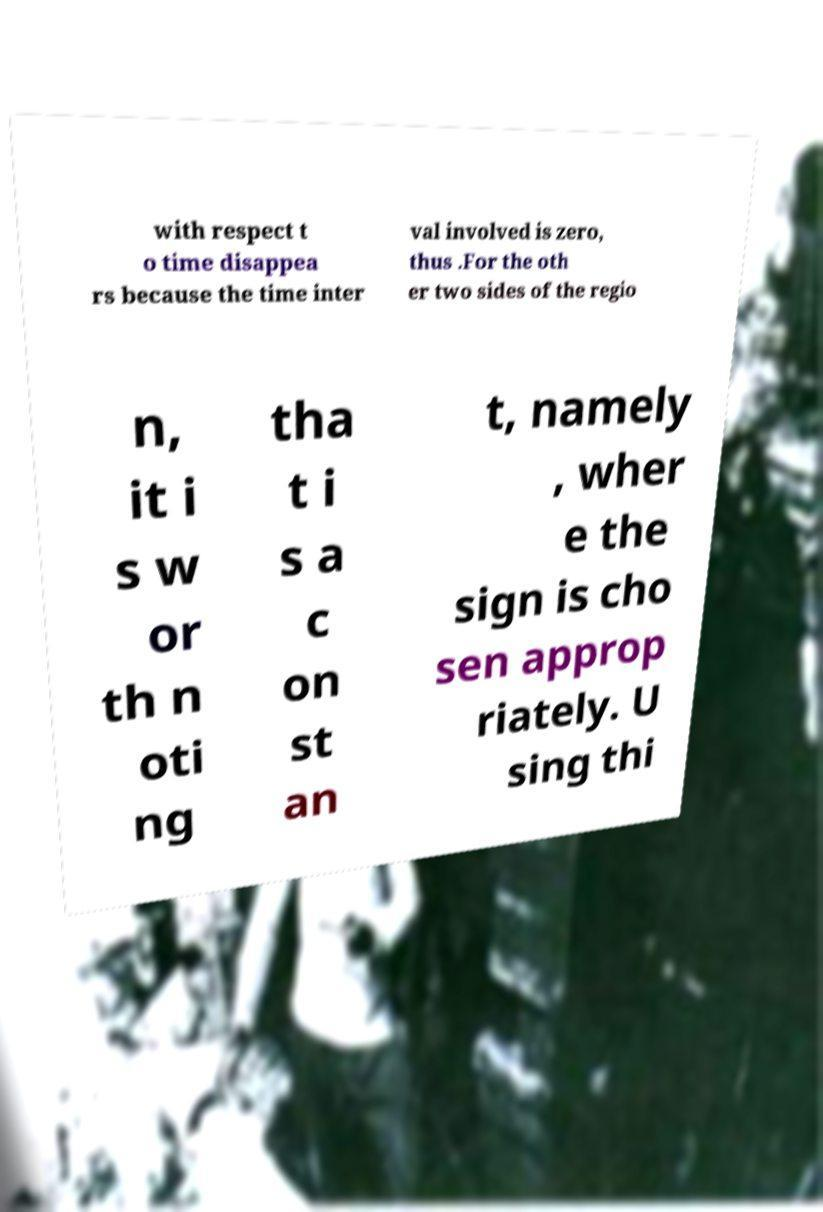Can you accurately transcribe the text from the provided image for me? with respect t o time disappea rs because the time inter val involved is zero, thus .For the oth er two sides of the regio n, it i s w or th n oti ng tha t i s a c on st an t, namely , wher e the sign is cho sen approp riately. U sing thi 